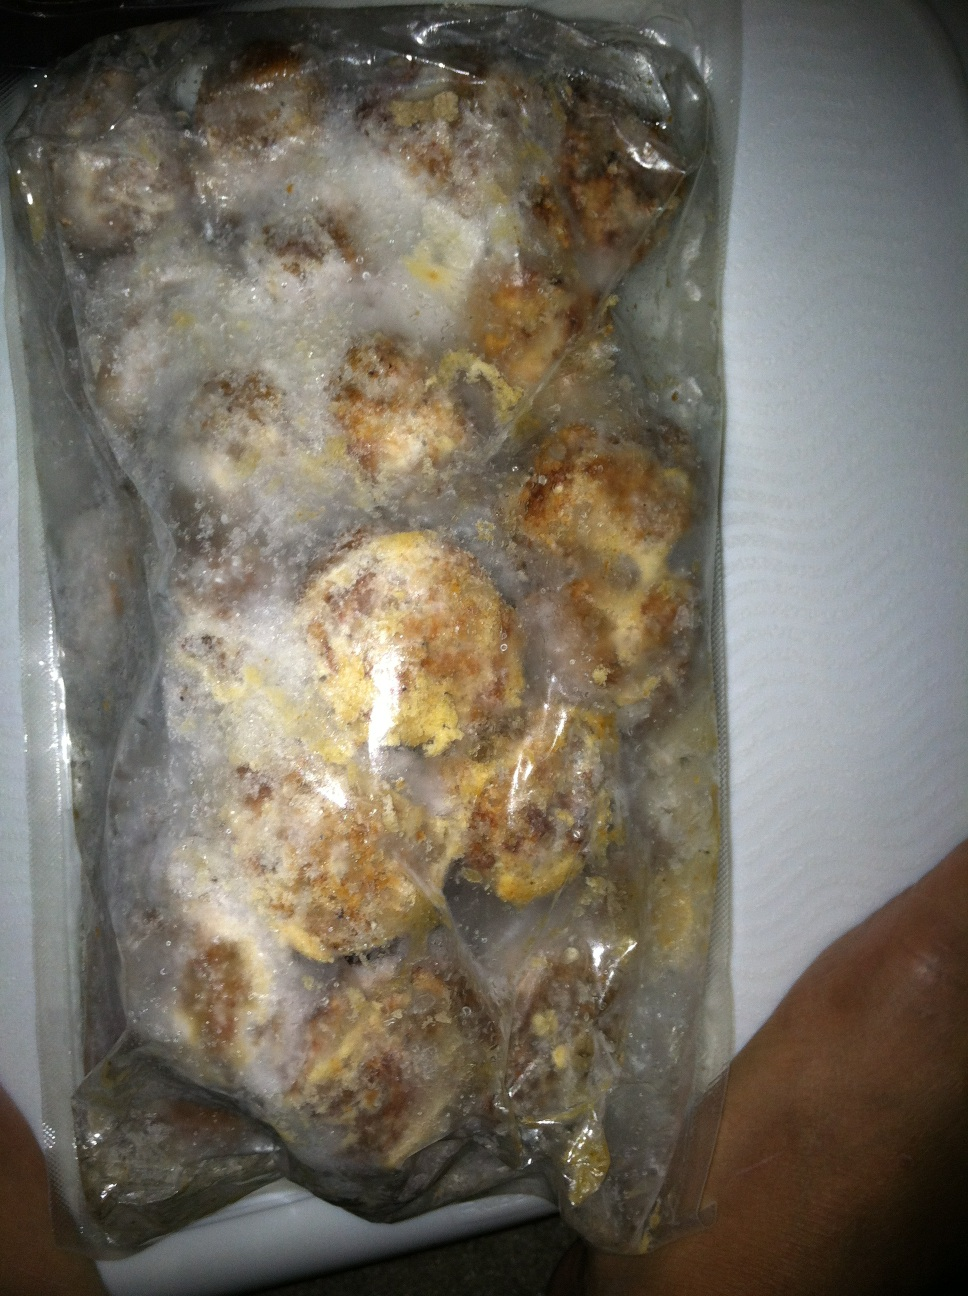Can you describe the contents of this package in detail? This package appears to contain spherical food items that are frozen. The food seems to be meatballs due to their round shape and brownish color. The frost and ice on them suggest they have been stored in a freezer for preservation. 